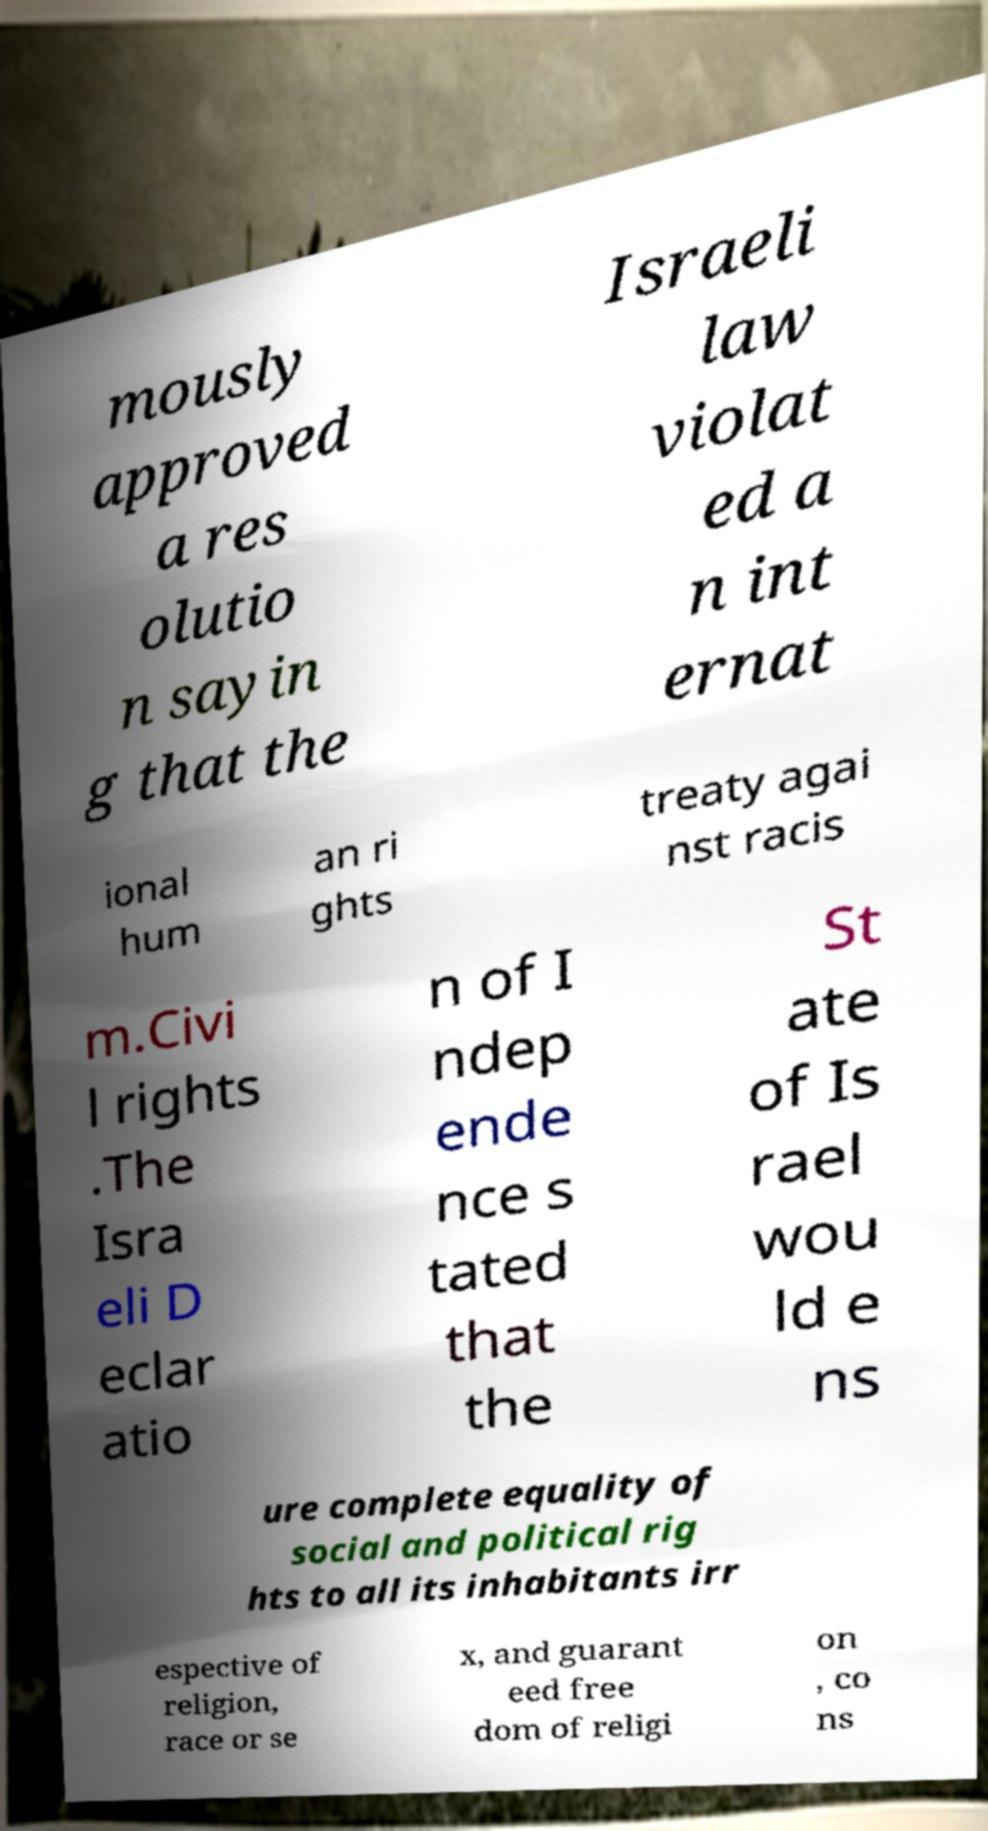Could you extract and type out the text from this image? mously approved a res olutio n sayin g that the Israeli law violat ed a n int ernat ional hum an ri ghts treaty agai nst racis m.Civi l rights .The Isra eli D eclar atio n of I ndep ende nce s tated that the St ate of Is rael wou ld e ns ure complete equality of social and political rig hts to all its inhabitants irr espective of religion, race or se x, and guarant eed free dom of religi on , co ns 